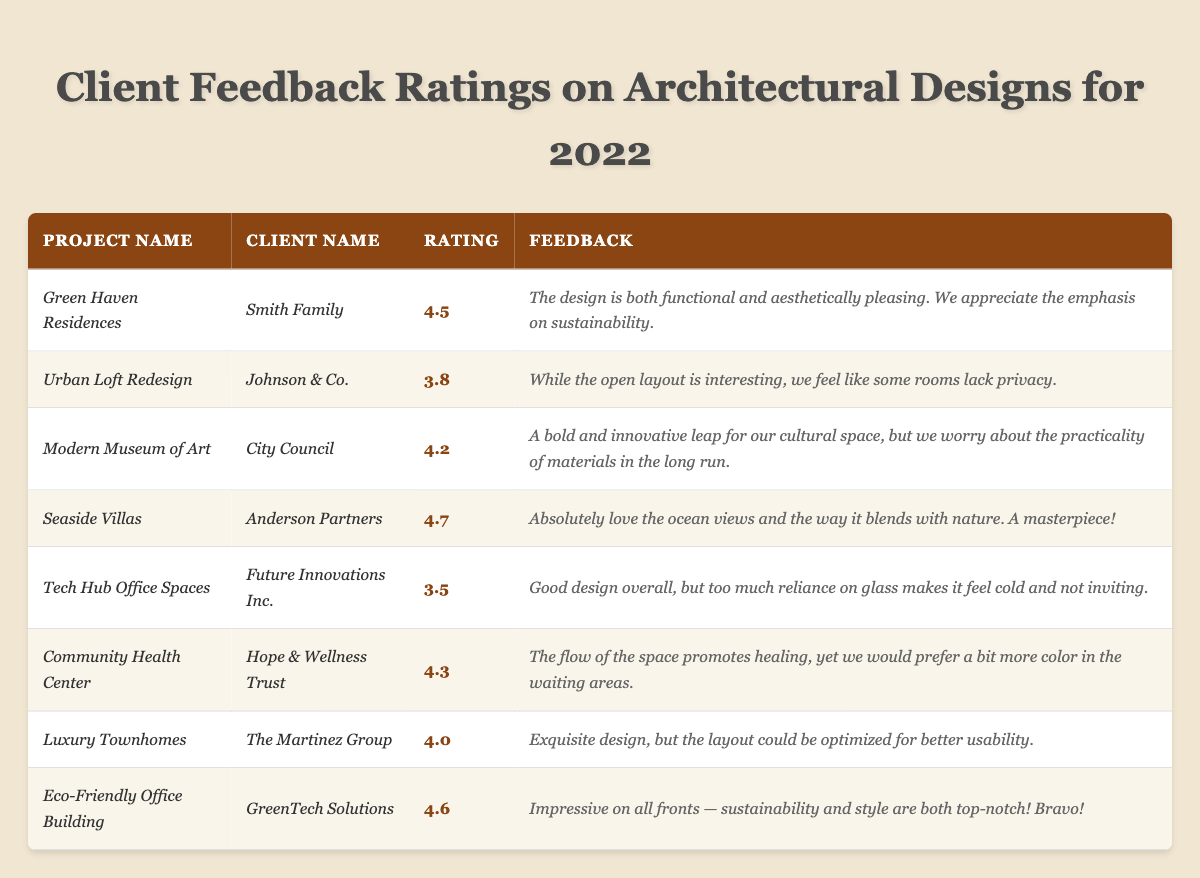What is the highest client feedback rating for a project? By reviewing the ratings for each project, *Seaside Villas* has the highest rating at 4.7.
Answer: 4.7 Which project received a rating of 4.3? Checking the ratings column shows that *Community Health Center* is the project with a rating of 4.3.
Answer: Community Health Center What is the average rating of all projects? Adding the ratings: (4.5 + 3.8 + 4.2 + 4.7 + 3.5 + 4.3 + 4.0 + 4.6) = 33.6. There are 8 projects, so the average is 33.6/8 = 4.2.
Answer: 4.2 Did any project have feedback mentioning 'sustainability'? Yes, *Green Haven Residences* and *Eco-Friendly Office Building* have feedback mentioning 'sustainability.'
Answer: Yes What is the difference between the highest and lowest ratings? The highest rating is 4.7 (for *Seaside Villas*), and the lowest is 3.5 (for *Tech Hub Office Spaces*). The difference is 4.7 - 3.5 = 1.2.
Answer: 1.2 Which project has feedback indicating a preferred color change in the waiting areas? The feedback for the *Community Health Center* indicates a preference for more color in the waiting areas.
Answer: Community Health Center Is there a project that received a rating below 4.0 and what is it? The only project with a rating below 4.0 is *Tech Hub Office Spaces*, which has a rating of 3.5.
Answer: Tech Hub Office Spaces How many projects received a rating above 4.0? The projects with ratings above 4.0 are *Green Haven Residences*, *Modern Museum of Art*, *Seaside Villas*, *Community Health Center*, *Luxury Townhomes*, and *Eco-Friendly Office Building*. That's a total of 6 projects.
Answer: 6 